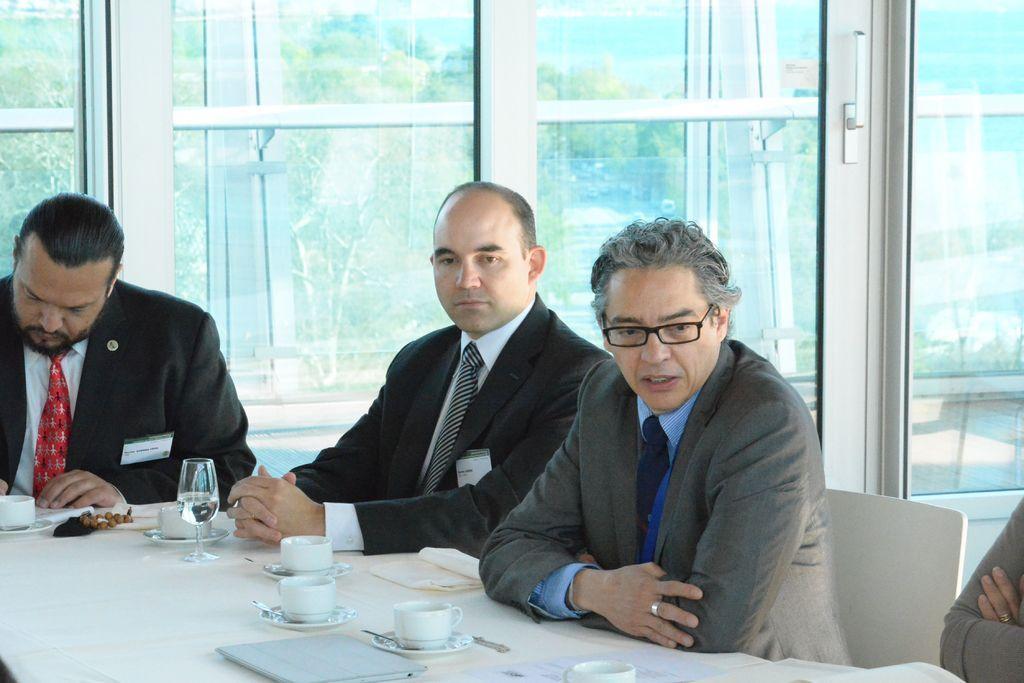Could you give a brief overview of what you see in this image? In this picture we can see a group of people sitting on the chairs. In front of the people, there is a table and on the table, there are cups, saucers, a glass, papers and some objects. Behind the people, there are glass windows. Behind the glass windows, there are trees. 